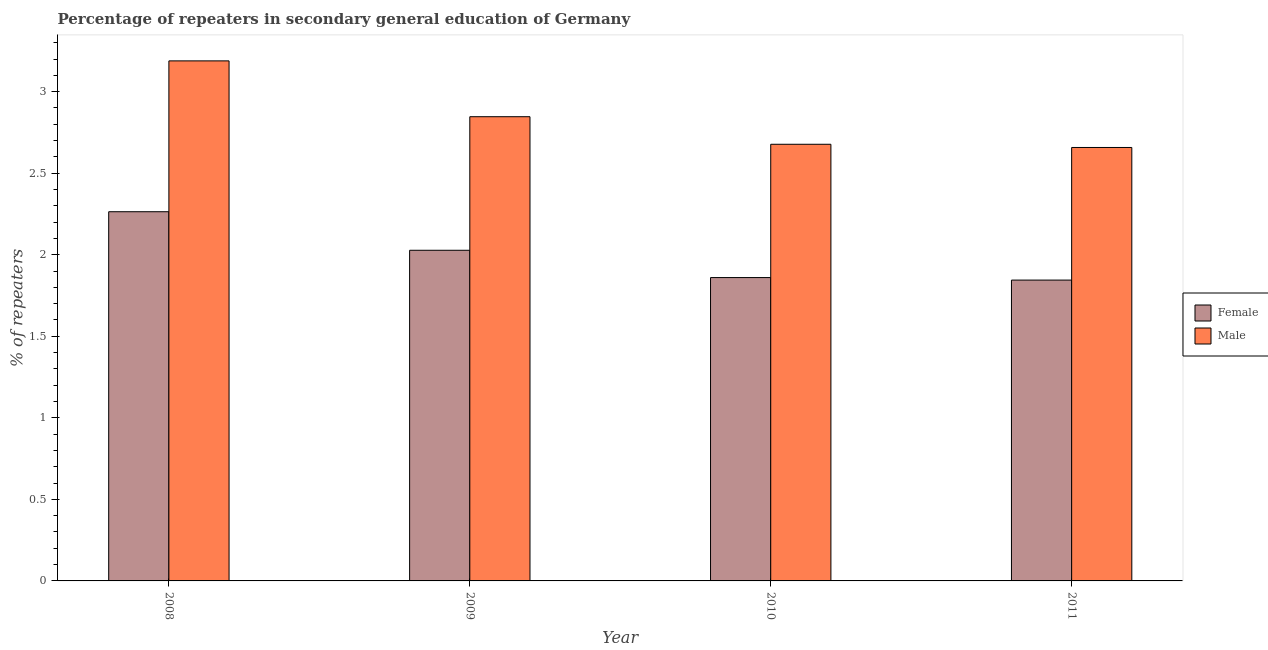How many different coloured bars are there?
Provide a succinct answer. 2. How many groups of bars are there?
Offer a very short reply. 4. Are the number of bars per tick equal to the number of legend labels?
Provide a short and direct response. Yes. How many bars are there on the 1st tick from the left?
Make the answer very short. 2. What is the label of the 2nd group of bars from the left?
Your response must be concise. 2009. In how many cases, is the number of bars for a given year not equal to the number of legend labels?
Offer a very short reply. 0. What is the percentage of female repeaters in 2008?
Ensure brevity in your answer.  2.26. Across all years, what is the maximum percentage of male repeaters?
Give a very brief answer. 3.19. Across all years, what is the minimum percentage of female repeaters?
Make the answer very short. 1.84. In which year was the percentage of male repeaters maximum?
Make the answer very short. 2008. What is the total percentage of female repeaters in the graph?
Make the answer very short. 8. What is the difference between the percentage of male repeaters in 2009 and that in 2011?
Provide a short and direct response. 0.19. What is the difference between the percentage of male repeaters in 2011 and the percentage of female repeaters in 2010?
Provide a succinct answer. -0.02. What is the average percentage of male repeaters per year?
Offer a very short reply. 2.84. In the year 2009, what is the difference between the percentage of male repeaters and percentage of female repeaters?
Ensure brevity in your answer.  0. In how many years, is the percentage of male repeaters greater than 0.8 %?
Your answer should be very brief. 4. What is the ratio of the percentage of male repeaters in 2008 to that in 2011?
Provide a short and direct response. 1.2. Is the difference between the percentage of male repeaters in 2009 and 2010 greater than the difference between the percentage of female repeaters in 2009 and 2010?
Provide a short and direct response. No. What is the difference between the highest and the second highest percentage of male repeaters?
Make the answer very short. 0.34. What is the difference between the highest and the lowest percentage of female repeaters?
Provide a succinct answer. 0.42. Are all the bars in the graph horizontal?
Offer a terse response. No. Are the values on the major ticks of Y-axis written in scientific E-notation?
Your response must be concise. No. Does the graph contain any zero values?
Provide a succinct answer. No. Does the graph contain grids?
Your answer should be compact. No. Where does the legend appear in the graph?
Ensure brevity in your answer.  Center right. How are the legend labels stacked?
Give a very brief answer. Vertical. What is the title of the graph?
Offer a very short reply. Percentage of repeaters in secondary general education of Germany. What is the label or title of the Y-axis?
Ensure brevity in your answer.  % of repeaters. What is the % of repeaters in Female in 2008?
Offer a very short reply. 2.26. What is the % of repeaters of Male in 2008?
Provide a succinct answer. 3.19. What is the % of repeaters in Female in 2009?
Your answer should be compact. 2.03. What is the % of repeaters in Male in 2009?
Your answer should be compact. 2.85. What is the % of repeaters in Female in 2010?
Keep it short and to the point. 1.86. What is the % of repeaters in Male in 2010?
Your answer should be compact. 2.68. What is the % of repeaters in Female in 2011?
Offer a terse response. 1.84. What is the % of repeaters of Male in 2011?
Offer a very short reply. 2.66. Across all years, what is the maximum % of repeaters of Female?
Give a very brief answer. 2.26. Across all years, what is the maximum % of repeaters of Male?
Provide a succinct answer. 3.19. Across all years, what is the minimum % of repeaters in Female?
Your response must be concise. 1.84. Across all years, what is the minimum % of repeaters of Male?
Ensure brevity in your answer.  2.66. What is the total % of repeaters in Female in the graph?
Ensure brevity in your answer.  8. What is the total % of repeaters of Male in the graph?
Ensure brevity in your answer.  11.37. What is the difference between the % of repeaters in Female in 2008 and that in 2009?
Offer a terse response. 0.24. What is the difference between the % of repeaters in Male in 2008 and that in 2009?
Offer a terse response. 0.34. What is the difference between the % of repeaters in Female in 2008 and that in 2010?
Provide a short and direct response. 0.4. What is the difference between the % of repeaters of Male in 2008 and that in 2010?
Provide a succinct answer. 0.51. What is the difference between the % of repeaters in Female in 2008 and that in 2011?
Keep it short and to the point. 0.42. What is the difference between the % of repeaters of Male in 2008 and that in 2011?
Provide a short and direct response. 0.53. What is the difference between the % of repeaters of Female in 2009 and that in 2010?
Provide a short and direct response. 0.17. What is the difference between the % of repeaters of Male in 2009 and that in 2010?
Provide a short and direct response. 0.17. What is the difference between the % of repeaters in Female in 2009 and that in 2011?
Provide a short and direct response. 0.18. What is the difference between the % of repeaters in Male in 2009 and that in 2011?
Your response must be concise. 0.19. What is the difference between the % of repeaters of Female in 2010 and that in 2011?
Make the answer very short. 0.02. What is the difference between the % of repeaters in Male in 2010 and that in 2011?
Provide a succinct answer. 0.02. What is the difference between the % of repeaters of Female in 2008 and the % of repeaters of Male in 2009?
Ensure brevity in your answer.  -0.58. What is the difference between the % of repeaters of Female in 2008 and the % of repeaters of Male in 2010?
Ensure brevity in your answer.  -0.41. What is the difference between the % of repeaters of Female in 2008 and the % of repeaters of Male in 2011?
Offer a very short reply. -0.39. What is the difference between the % of repeaters in Female in 2009 and the % of repeaters in Male in 2010?
Your answer should be very brief. -0.65. What is the difference between the % of repeaters of Female in 2009 and the % of repeaters of Male in 2011?
Give a very brief answer. -0.63. What is the difference between the % of repeaters of Female in 2010 and the % of repeaters of Male in 2011?
Your answer should be compact. -0.8. What is the average % of repeaters of Female per year?
Provide a short and direct response. 2. What is the average % of repeaters in Male per year?
Ensure brevity in your answer.  2.84. In the year 2008, what is the difference between the % of repeaters in Female and % of repeaters in Male?
Make the answer very short. -0.93. In the year 2009, what is the difference between the % of repeaters in Female and % of repeaters in Male?
Offer a very short reply. -0.82. In the year 2010, what is the difference between the % of repeaters of Female and % of repeaters of Male?
Your answer should be compact. -0.82. In the year 2011, what is the difference between the % of repeaters of Female and % of repeaters of Male?
Your answer should be compact. -0.81. What is the ratio of the % of repeaters in Female in 2008 to that in 2009?
Your answer should be very brief. 1.12. What is the ratio of the % of repeaters in Male in 2008 to that in 2009?
Provide a short and direct response. 1.12. What is the ratio of the % of repeaters of Female in 2008 to that in 2010?
Provide a short and direct response. 1.22. What is the ratio of the % of repeaters in Male in 2008 to that in 2010?
Offer a terse response. 1.19. What is the ratio of the % of repeaters of Female in 2008 to that in 2011?
Your answer should be very brief. 1.23. What is the ratio of the % of repeaters of Male in 2008 to that in 2011?
Keep it short and to the point. 1.2. What is the ratio of the % of repeaters of Female in 2009 to that in 2010?
Ensure brevity in your answer.  1.09. What is the ratio of the % of repeaters in Male in 2009 to that in 2010?
Give a very brief answer. 1.06. What is the ratio of the % of repeaters of Female in 2009 to that in 2011?
Your answer should be very brief. 1.1. What is the ratio of the % of repeaters of Male in 2009 to that in 2011?
Offer a terse response. 1.07. What is the ratio of the % of repeaters of Female in 2010 to that in 2011?
Your answer should be compact. 1.01. What is the ratio of the % of repeaters of Male in 2010 to that in 2011?
Make the answer very short. 1.01. What is the difference between the highest and the second highest % of repeaters of Female?
Your answer should be very brief. 0.24. What is the difference between the highest and the second highest % of repeaters of Male?
Your answer should be compact. 0.34. What is the difference between the highest and the lowest % of repeaters in Female?
Make the answer very short. 0.42. What is the difference between the highest and the lowest % of repeaters of Male?
Provide a short and direct response. 0.53. 